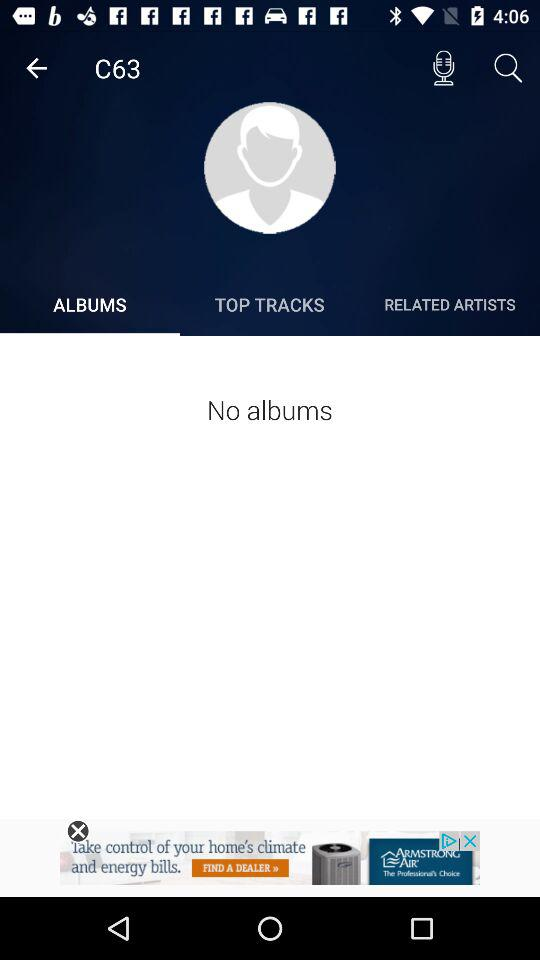How many albums does the artist have?
Answer the question using a single word or phrase. 0 